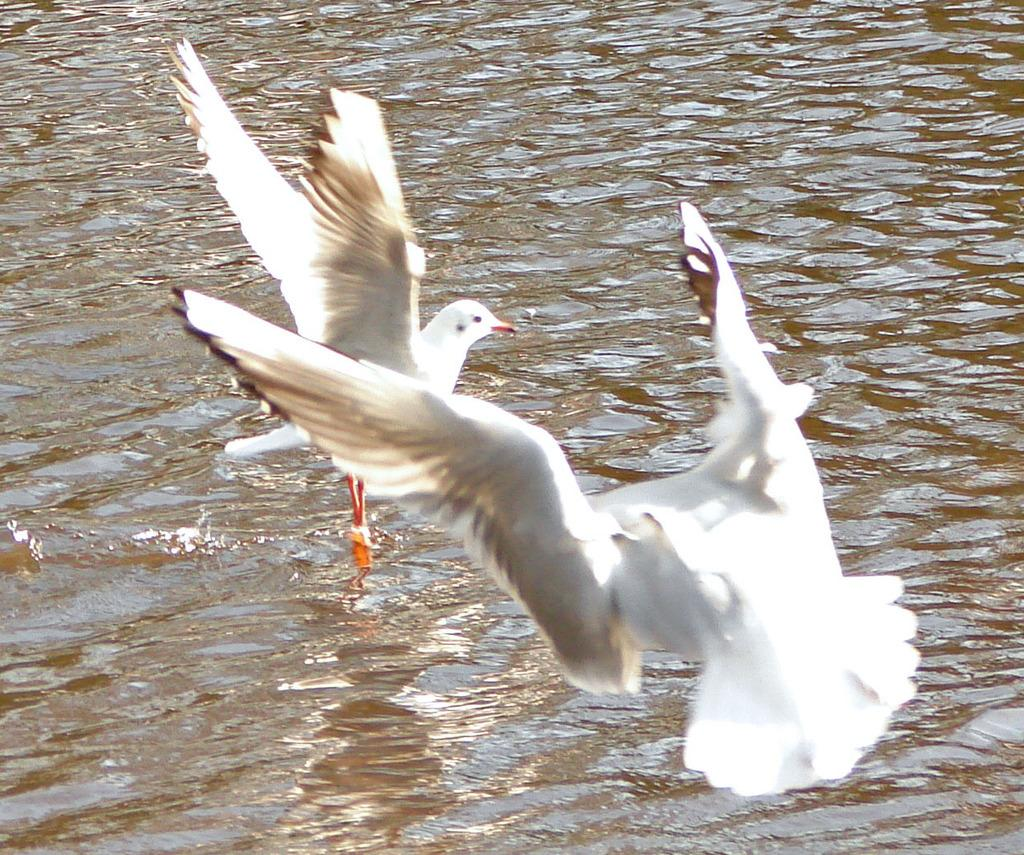What type of animals can be seen in the image? There are two white color birds in the image. What are the birds doing in the image? The birds are flying in the air. Where are the birds located in relation to the water? The birds are above the water surface. What type of writing can be seen on the birds' wings in the image? There is no writing visible on the birds' wings in the image. 